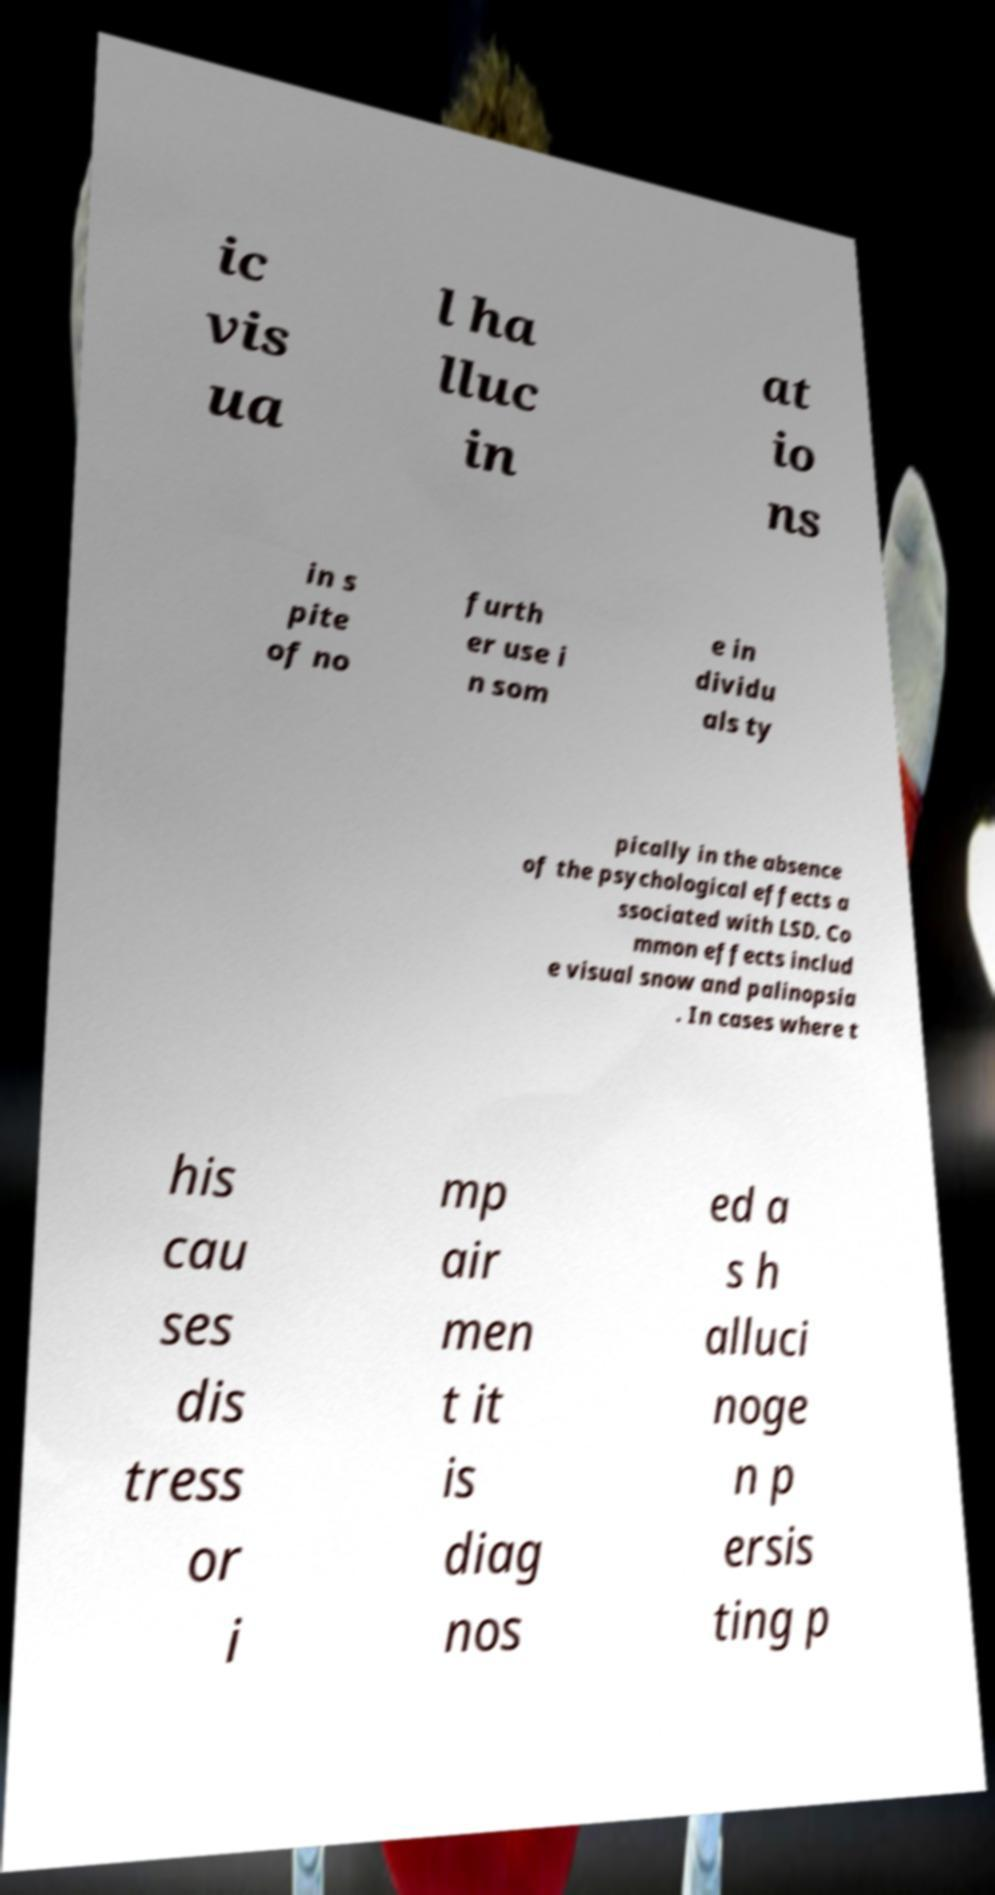Please identify and transcribe the text found in this image. ic vis ua l ha lluc in at io ns in s pite of no furth er use i n som e in dividu als ty pically in the absence of the psychological effects a ssociated with LSD. Co mmon effects includ e visual snow and palinopsia . In cases where t his cau ses dis tress or i mp air men t it is diag nos ed a s h alluci noge n p ersis ting p 